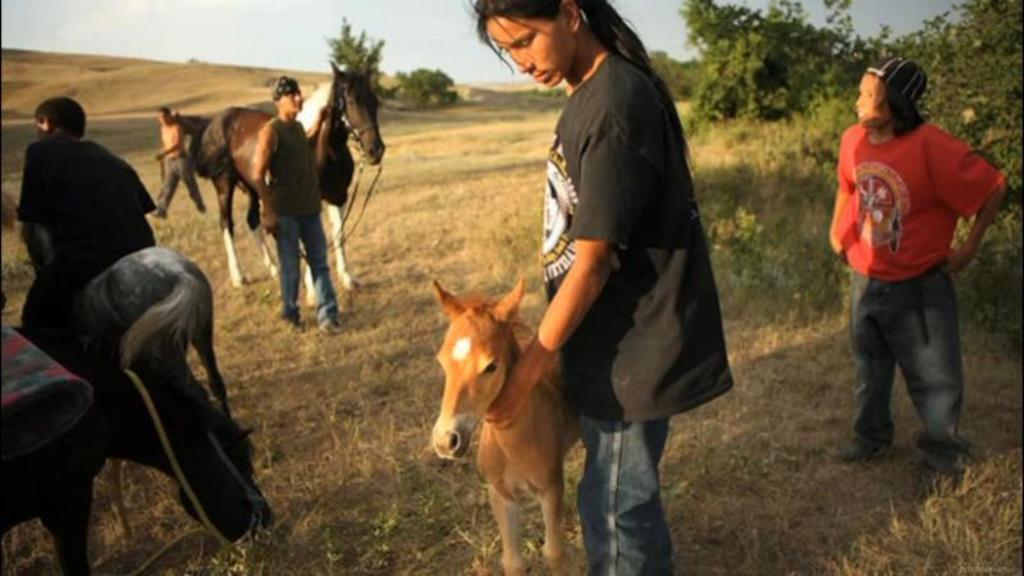What is happening in the image involving people? There are people standing in the image, and a man is riding a horse. How is the man interacting with the horse? The man is holding the horse with his hands. What is the woman doing in the image? The woman is holding a pony. What can be seen in the background of the image? There are plants visible in the image. What type of force is being applied to the boats in the image? There are no boats present in the image, so the concept of force cannot be applied to them. 